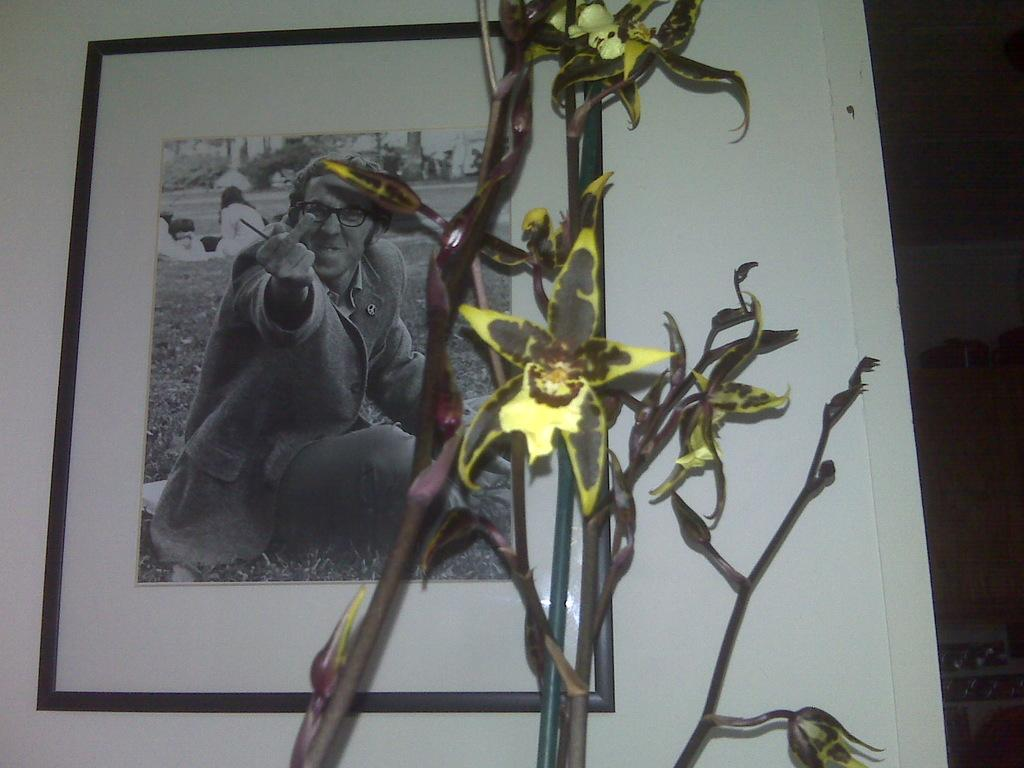What type of living organism can be seen in the image? There is a plant in the image. What is located behind the plant in the image? There is a frame hanging on the wall behind the plant. How does the plant turn around in the image? The plant does not turn around in the image; it is stationary. 